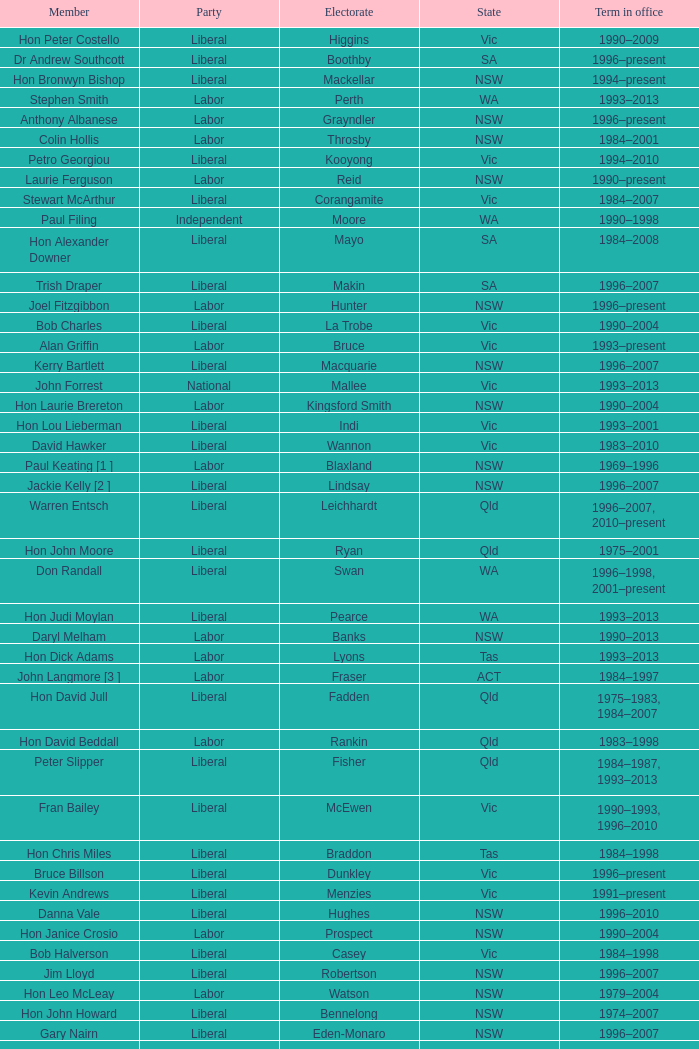In what state was the electorate fowler? NSW. 